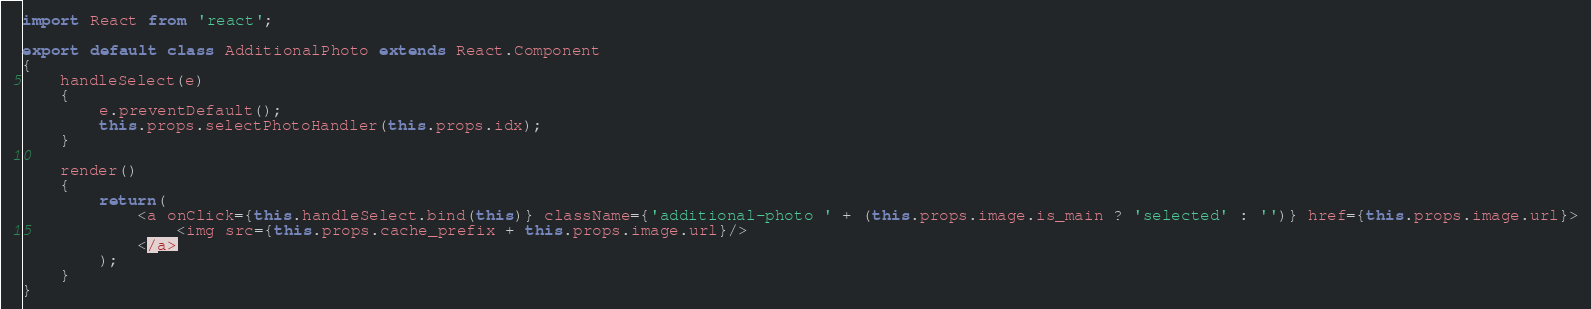Convert code to text. <code><loc_0><loc_0><loc_500><loc_500><_JavaScript_>import React from 'react';

export default class AdditionalPhoto extends React.Component
{
    handleSelect(e)
    {
        e.preventDefault();
        this.props.selectPhotoHandler(this.props.idx);
    }

    render()
    {
        return(
            <a onClick={this.handleSelect.bind(this)} className={'additional-photo ' + (this.props.image.is_main ? 'selected' : '')} href={this.props.image.url}>
                <img src={this.props.cache_prefix + this.props.image.url}/>
            </a>
        );
    }
}</code> 